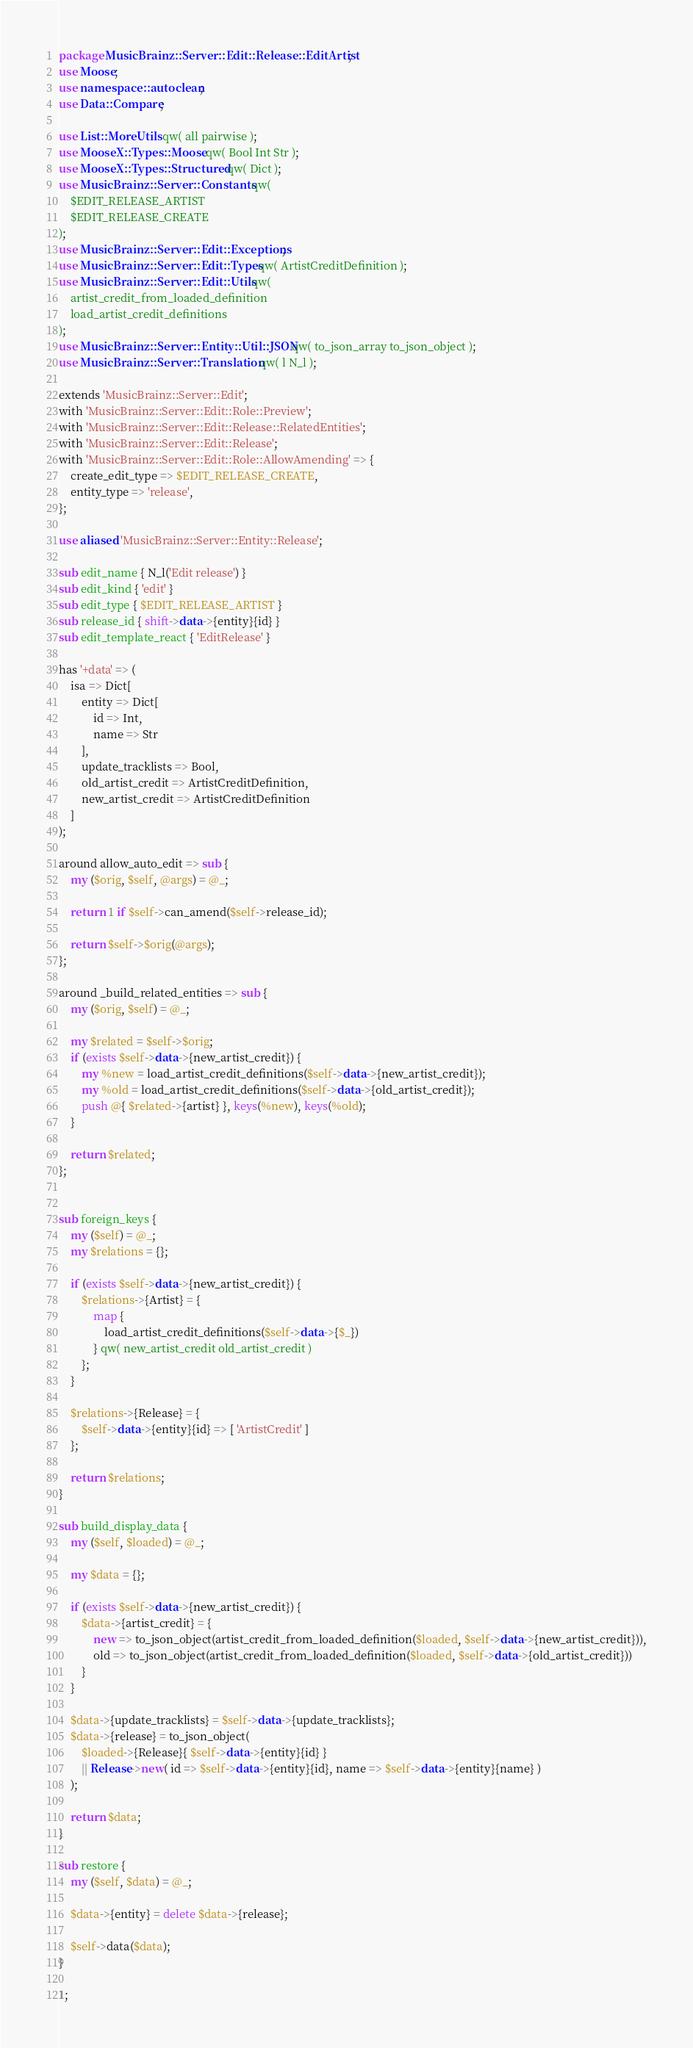Convert code to text. <code><loc_0><loc_0><loc_500><loc_500><_Perl_>package MusicBrainz::Server::Edit::Release::EditArtist;
use Moose;
use namespace::autoclean;
use Data::Compare;

use List::MoreUtils qw( all pairwise );
use MooseX::Types::Moose qw( Bool Int Str );
use MooseX::Types::Structured qw( Dict );
use MusicBrainz::Server::Constants qw(
    $EDIT_RELEASE_ARTIST
    $EDIT_RELEASE_CREATE
);
use MusicBrainz::Server::Edit::Exceptions;
use MusicBrainz::Server::Edit::Types qw( ArtistCreditDefinition );
use MusicBrainz::Server::Edit::Utils qw(
    artist_credit_from_loaded_definition
    load_artist_credit_definitions
);
use MusicBrainz::Server::Entity::Util::JSON qw( to_json_array to_json_object );
use MusicBrainz::Server::Translation qw( l N_l );

extends 'MusicBrainz::Server::Edit';
with 'MusicBrainz::Server::Edit::Role::Preview';
with 'MusicBrainz::Server::Edit::Release::RelatedEntities';
with 'MusicBrainz::Server::Edit::Release';
with 'MusicBrainz::Server::Edit::Role::AllowAmending' => {
    create_edit_type => $EDIT_RELEASE_CREATE,
    entity_type => 'release',
};

use aliased 'MusicBrainz::Server::Entity::Release';

sub edit_name { N_l('Edit release') }
sub edit_kind { 'edit' }
sub edit_type { $EDIT_RELEASE_ARTIST }
sub release_id { shift->data->{entity}{id} }
sub edit_template_react { 'EditRelease' }

has '+data' => (
    isa => Dict[
        entity => Dict[
            id => Int,
            name => Str
        ],
        update_tracklists => Bool,
        old_artist_credit => ArtistCreditDefinition,
        new_artist_credit => ArtistCreditDefinition
    ]
);

around allow_auto_edit => sub {
    my ($orig, $self, @args) = @_;

    return 1 if $self->can_amend($self->release_id);

    return $self->$orig(@args);
};

around _build_related_entities => sub {
    my ($orig, $self) = @_;

    my $related = $self->$orig;
    if (exists $self->data->{new_artist_credit}) {
        my %new = load_artist_credit_definitions($self->data->{new_artist_credit});
        my %old = load_artist_credit_definitions($self->data->{old_artist_credit});
        push @{ $related->{artist} }, keys(%new), keys(%old);
    }

    return $related;
};


sub foreign_keys {
    my ($self) = @_;
    my $relations = {};

    if (exists $self->data->{new_artist_credit}) {
        $relations->{Artist} = {
            map {
                load_artist_credit_definitions($self->data->{$_})
            } qw( new_artist_credit old_artist_credit )
        };
    }

    $relations->{Release} = {
        $self->data->{entity}{id} => [ 'ArtistCredit' ]
    };

    return $relations;
}

sub build_display_data {
    my ($self, $loaded) = @_;

    my $data = {};

    if (exists $self->data->{new_artist_credit}) {
        $data->{artist_credit} = {
            new => to_json_object(artist_credit_from_loaded_definition($loaded, $self->data->{new_artist_credit})),
            old => to_json_object(artist_credit_from_loaded_definition($loaded, $self->data->{old_artist_credit}))
        }
    }

    $data->{update_tracklists} = $self->data->{update_tracklists};
    $data->{release} = to_json_object(
        $loaded->{Release}{ $self->data->{entity}{id} }
        || Release->new( id => $self->data->{entity}{id}, name => $self->data->{entity}{name} )
    );

    return $data;
}

sub restore {
    my ($self, $data) = @_;

    $data->{entity} = delete $data->{release};

    $self->data($data);
}

1;
</code> 